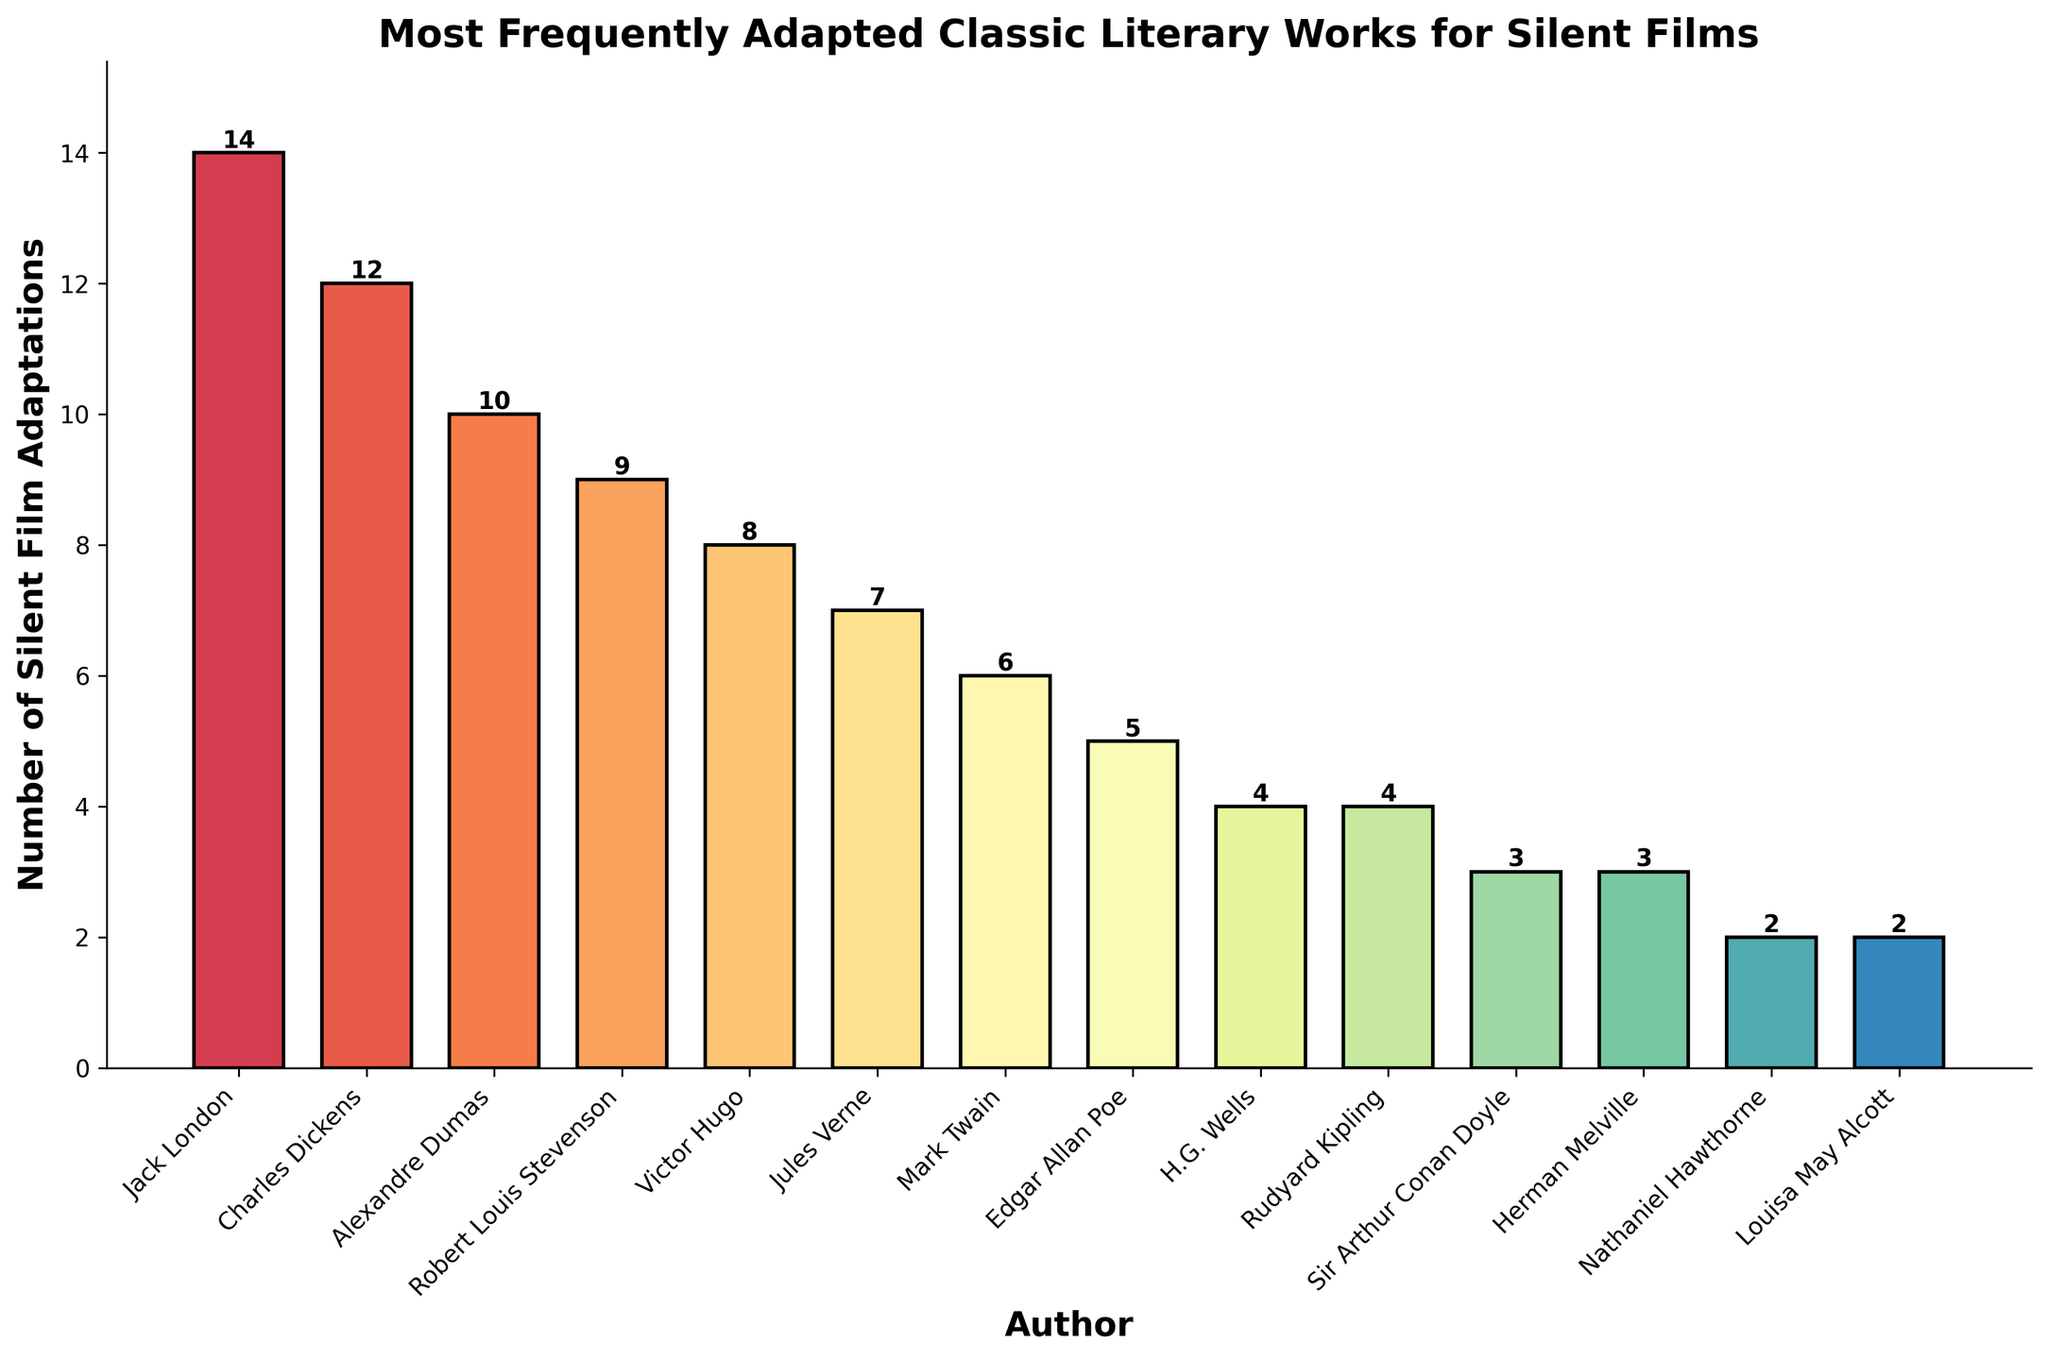What is the author with the highest number of silent film adaptations? The highest bar represents Jack London with 14 adaptations.
Answer: Jack London Which author has more silent film adaptations, Charles Dickens or Victor Hugo? Charles Dickens has 12 adaptations, and Victor Hugo has 8. Dickens has more than Hugo.
Answer: Charles Dickens How many more silent film adaptations does Jack London have compared to Edgar Allan Poe? Jack London has 14 adaptations while Edgar Allan Poe has 5. The difference is 14 - 5.
Answer: 9 What is the sum of silent film adaptations for Alexandre Dumas and H.G. Wells? Alexandre Dumas has 10 adaptations and H.G. Wells has 4. Summing them gives 10 + 4.
Answer: 14 Which authors are tied in the number of silent film adaptations at 4? The bars in the chart show two authors with 4 adaptations: H.G. Wells and Rudyard Kipling.
Answer: H.G. Wells, Rudyard Kipling What is the average number of silent film adaptations of Jules Verne, Mark Twain, and Charles Dickens? Jules Verne has 7, Mark Twain has 6, and Charles Dickens has 12. The average is (7 + 6 + 12) / 3.
Answer: 8.33 Who adapted more silent films, Robert Louis Stevenson or Nathaniel Hawthorne? Robert Louis Stevenson has 9 adaptations, while Nathaniel Hawthorne has 2. Stevenson adapted more.
Answer: Robert Louis Stevenson How many total silent film adaptations are there for authors with less than 5 adaptations each? The authors with less than 5 adaptations are Sir Arthur Conan Doyle (3), Herman Melville (3), Nathaniel Hawthorne (2), and Louisa May Alcott (2). The total is 3 + 3 + 2 + 2.
Answer: 10 